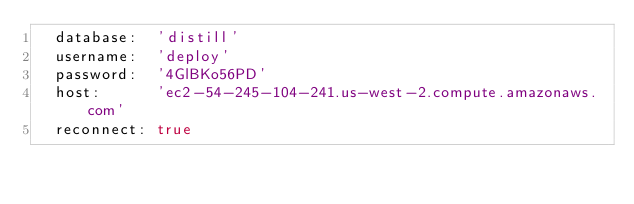Convert code to text. <code><loc_0><loc_0><loc_500><loc_500><_YAML_>  database:  'distill'
  username:  'deploy'
  password:  '4GlBKo56PD'
  host:      'ec2-54-245-104-241.us-west-2.compute.amazonaws.com'
  reconnect: true


</code> 